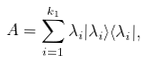Convert formula to latex. <formula><loc_0><loc_0><loc_500><loc_500>A = \sum _ { i = 1 } ^ { k _ { 1 } } \lambda _ { i } | \lambda _ { i } \rangle \langle \lambda _ { i } | ,</formula> 